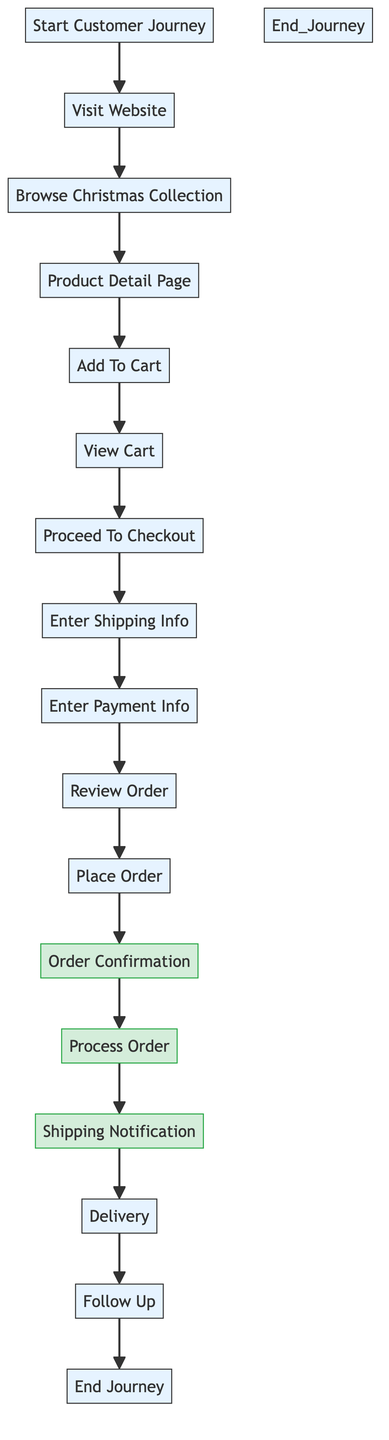What is the first step in the customer purchase journey? The first step is labeled "Start Customer Journey" in the diagram, indicating where the flow begins.
Answer: Start Customer Journey How many main steps are involved in the customer purchase journey? By counting the elements represented as nodes in the flowchart, we can identify 15 steps included in the journey.
Answer: 15 What is the last step of the customer purchase journey? The last step is labeled "End Customer Journey," which indicates the conclusion of the process flow.
Answer: End Customer Journey Which step follows the "Enter Payment Info"? According to the flow direction shown in the diagram, "Review Order" directly follows the "Enter Payment Info" step in the customer journey.
Answer: Review Order What does the "Order Confirmation" step represent? The "Order Confirmation" step indicates that the customer receives an email confirming their order, which is an important touchpoint in the journey.
Answer: Order Confirmation What characterizes the steps "Process Order," "Order Confirmation," and "Shipping Notification"? These three steps are categorized as process nodes, indicating that they are part of the operational workflow in fulfilling customer orders.
Answer: Process nodes Which two steps are directly connected to the "Shipping Notification"? The "Shipping Notification" step is directly preceded by "Process Order" and leads into "Delivery," creating a clear progression in the customer journey.
Answer: Process Order and Delivery What is the purpose of the "Follow Up" step? The "Follow Up" step is intended for the store to send a follow-up email, typically for gathering feedback or promoting future sales.
Answer: Follow Up In which step does the customer input their shipping information? The customer inputs their shipping information during the "Enter Shipping Info" step, which is marked in the flow of the customer journey.
Answer: Enter Shipping Info 